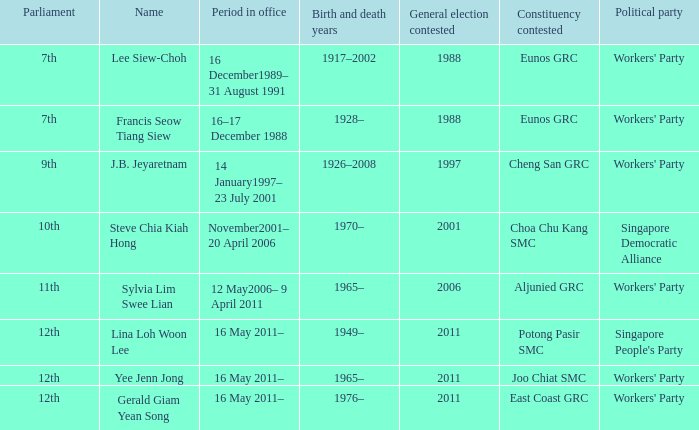What period were conscituency contested is aljunied grc? 12 May2006– 9 April 2011. 